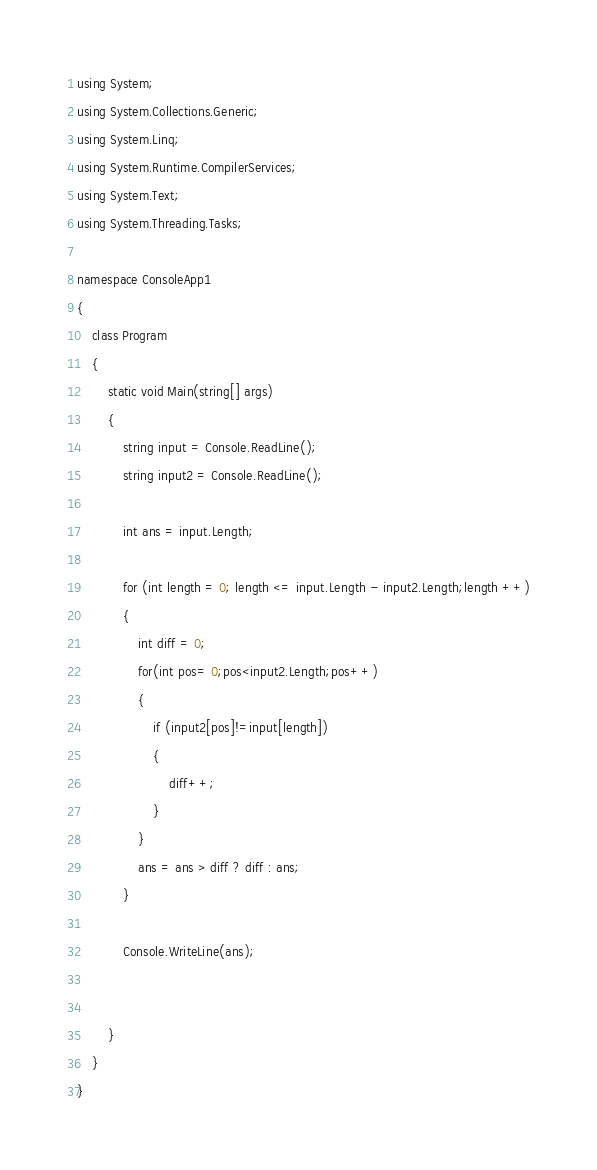<code> <loc_0><loc_0><loc_500><loc_500><_C#_>using System;
using System.Collections.Generic;
using System.Linq;
using System.Runtime.CompilerServices;
using System.Text;
using System.Threading.Tasks;

namespace ConsoleApp1
{
    class Program
    {
        static void Main(string[] args)
        {
            string input = Console.ReadLine();
            string input2 = Console.ReadLine();

            int ans = input.Length;

            for (int length = 0; length <= input.Length - input2.Length;length ++)
            {
                int diff = 0;
                for(int pos= 0;pos<input2.Length;pos++)
                {
                    if (input2[pos]!=input[length])
                    {
                        diff++;
                    }
                }
                ans = ans > diff ? diff : ans; 
            }

            Console.WriteLine(ans);


        }
    }
}
</code> 